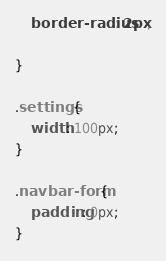Convert code to text. <code><loc_0><loc_0><loc_500><loc_500><_CSS_>    border-radius: 2px;
    
}

.settings {
    width: 100px;
}

.navbar-form {
    padding: 0px;
}</code> 